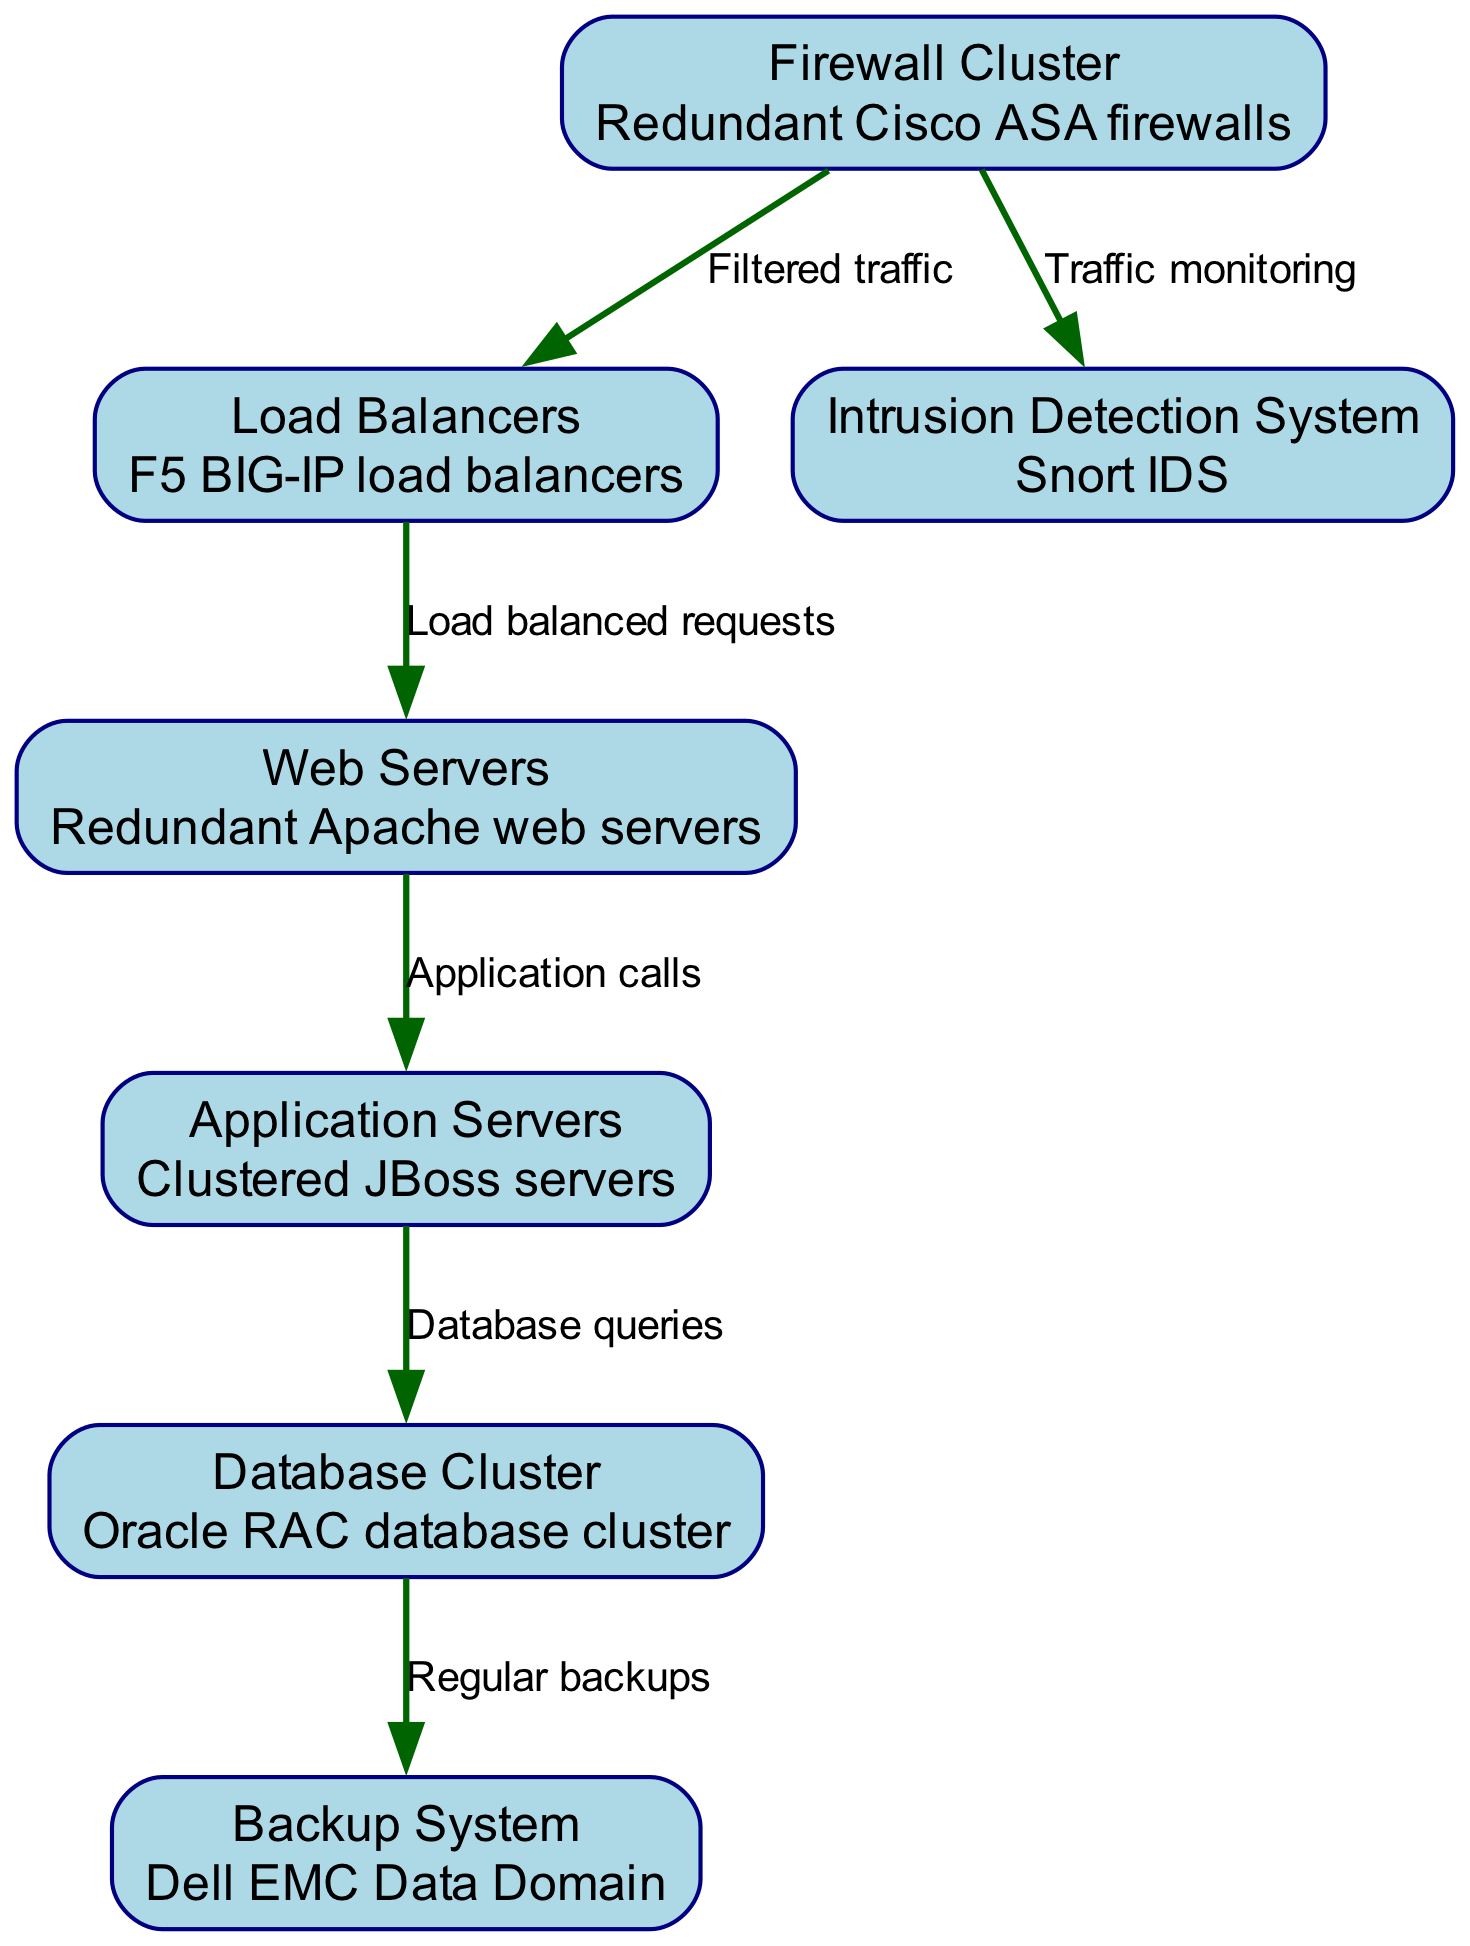What are the redundant devices shown at the beginning of the diagram? The diagram starts with a "Firewall Cluster," which consists of redundant Cisco ASA firewalls, indicating a focus on security by using multiple devices to handle traffic filtering.
Answer: Firewall Cluster How many nodes are there in the diagram? By counting the number of unique elements in the nodes section, we find there are seven individual components making up the system's network structure.
Answer: Seven What type of system is used for intrusion detection? The diagram specifies that the "Intrusion Detection System" employs Snort IDS, which indicates the technology chosen for monitoring potential threats within the network.
Answer: Snort IDS What is the relationship between the Web Servers and Application Servers? The edge connecting these nodes is labeled "Application calls," indicating that web servers send requests to application servers to retrieve or process data necessary to service users.
Answer: Application calls Which system is responsible for regular backups? The diagram clearly indicates that the "Backup System" is represented by Dell EMC Data Domain, illustrating its role in securing data through consistent backup processes.
Answer: Dell EMC Data Domain What labels are used between the Firewall Cluster and Load Balancers? The edge between these two nodes is labeled "Filtered traffic," showing that only traffic that meets certain security criteria set by the firewall is forwarded to the load balancers.
Answer: Filtered traffic What redundancy measures are indicated in the database section of the diagram? The "Database Cluster" is described as an Oracle RAC (Real Application Clusters), emphasizing that it is designed for high availability by distributing the database across multiple servers.
Answer: Oracle RAC database cluster How do the Load Balancers interact with Web Servers? The connection between Load Balancers and Web Servers is labeled "Load balanced requests," meaning the load balancers distribute incoming requests evenly to ensure no single web server becomes overwhelmed.
Answer: Load balanced requests Which component monitors traffic in this network infrastructure diagram? The "Intrusion Detection System" is identified in the diagram, revealing its purpose to observe and analyze traffic in the network for any suspicious activity.
Answer: Intrusion Detection System 